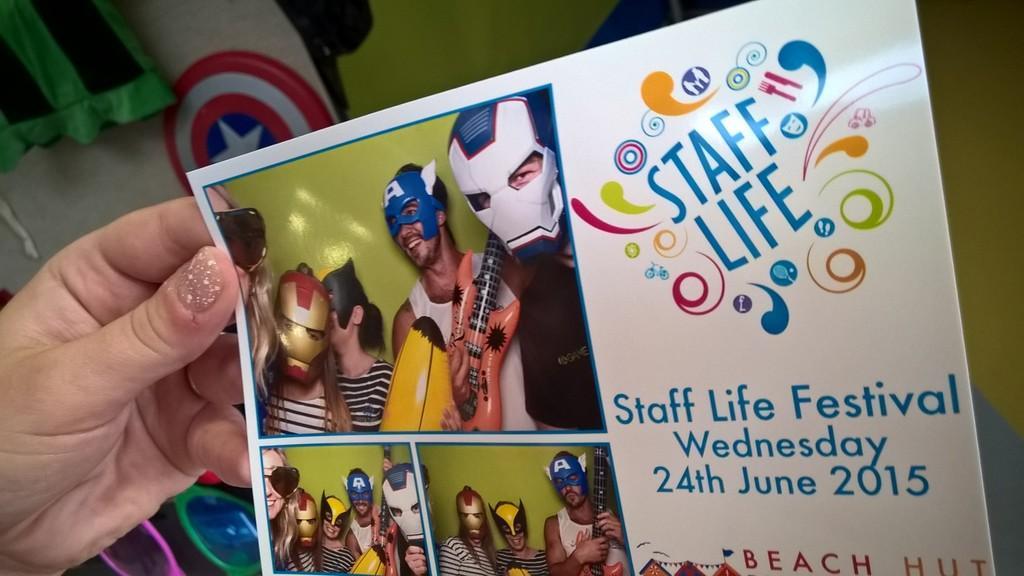In one or two sentences, can you explain what this image depicts? In the image in the center, we can see one hand holding one poster. On the poster, we can see a few people are standing and they are in different costumes. And they are holding some musical instruments and they are smiling. And we can see something written on the poster. In the background there is a wall, cloth, board and a few other objects. 